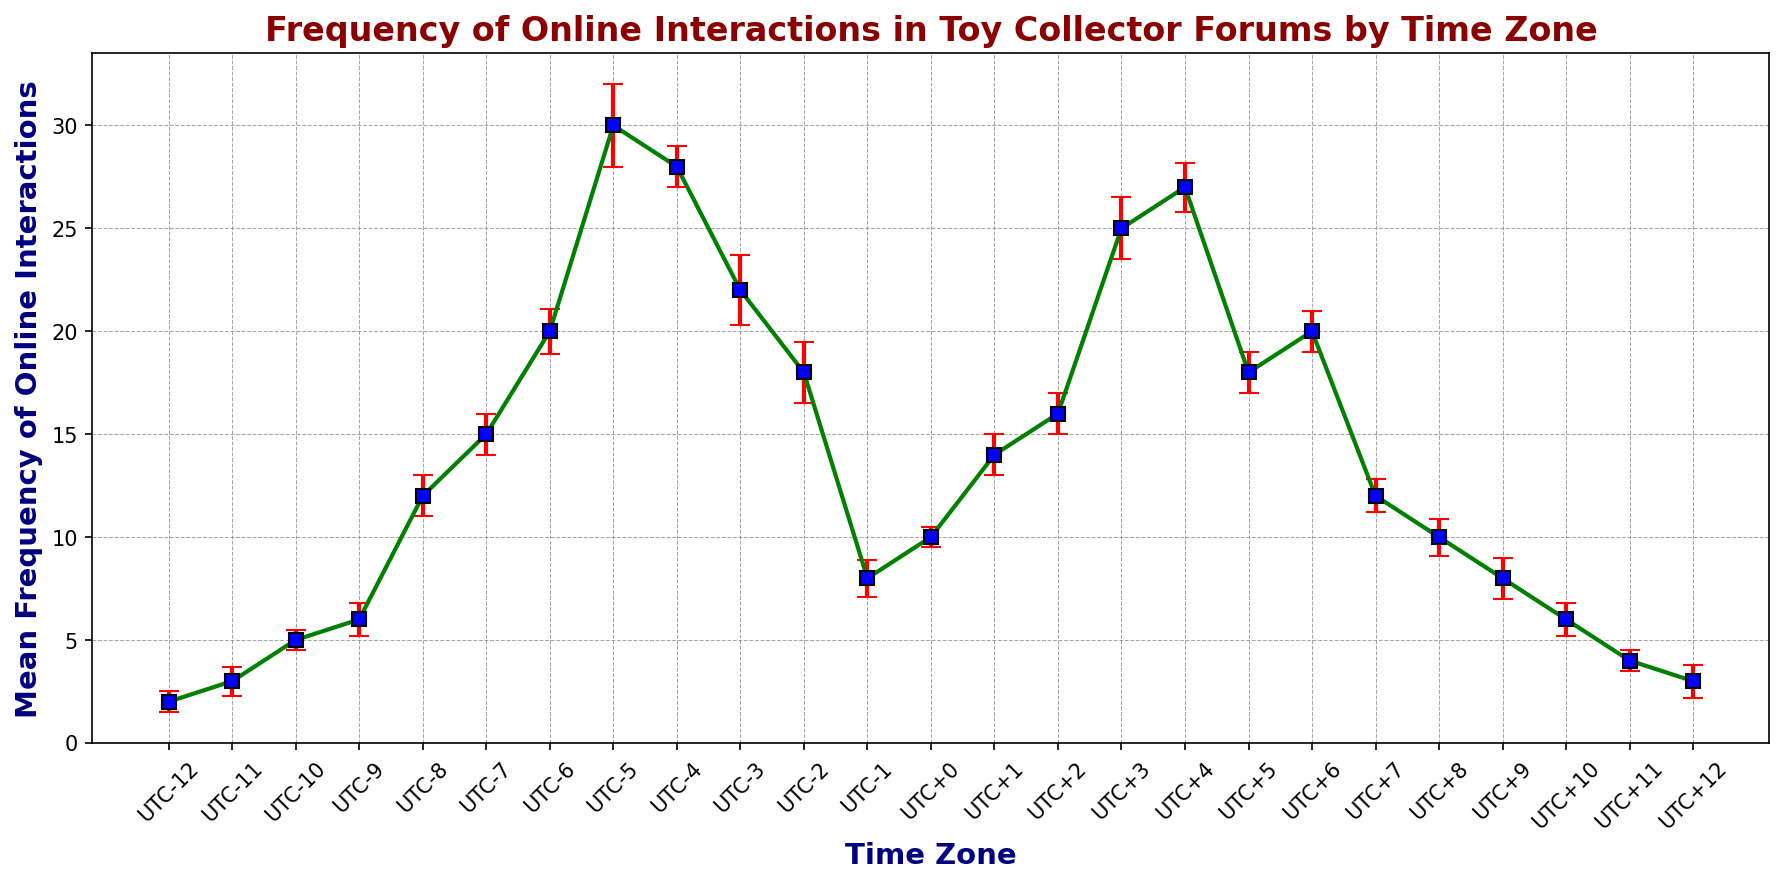Which time zone has the highest mean frequency of online interactions? The chart shows that the UTC-5 time zone has the highest mean frequency with its point being the tallest among all.
Answer: UTC-5 By how much does the mean frequency of online interactions in UTC+3 exceed that in UTC+2? The mean frequency in UTC+3 is 25, and in UTC+2 it is 16. Subtracting these gives 25 - 16 = 9.
Answer: 9 Which time zone has the smallest uncertainty interval for the mean frequency? The width of the uncertainty interval can be deduced from the length of the error bars. The smallest interval is observed for UTC-8, with bounds 11 and 13, making it the smallest range (13 - 11 = 2).
Answer: UTC-8 How do the mean frequencies of UTC+4 and UTC-4 compare to each other? The mean frequencies for UTC+4 and UTC-4 are 27 and 28 respectively, so UTC-4’s frequency is slightly higher.
Answer: UTC-4 has a higher frequency What is the range of mean frequencies shown in the chart? The highest mean is 30 (UTC-5) and the lowest mean is 2 (UTC-12). The range is calculated as 30 - 2 = 28.
Answer: 28 Which time zone has the lowest mean frequency and what is the corresponding uncertainty interval? The lowest mean frequency is 2 for UTC-12, with uncertainty bounds ranging from 1.5 to 2.5.
Answer: UTC-12, [1.5, 2.5] What is the average mean frequency for the time zones between UTC-2 and UTC+2? The time zones from UTC-2 to UTC+2 are UTC-2 (18), UTC-1 (8), UTC+0 (10), and UTC+1 (14), and UTC+2 (16). The sum is 18 + 8 + 10 + 14 + 16 = 66. The average is 66 / 5 = 13.2.
Answer: 13.2 Which time zone has the greatest difference between the upper and lower bounds of its 95% confidence interval? The largest difference is found by checking the intervals for all time zones. For UTC-5 the interval is [28, 32], yielding a difference of 4 units, which is the largest difference in the chart.
Answer: UTC-5 